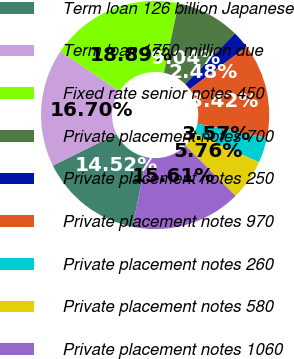<chart> <loc_0><loc_0><loc_500><loc_500><pie_chart><fcel>Term loan 126 billion Japanese<fcel>Term loan 1750 million due<fcel>Fixed rate senior notes 450<fcel>Private placement notes 700<fcel>Private placement notes 250<fcel>Private placement notes 970<fcel>Private placement notes 260<fcel>Private placement notes 580<fcel>Private placement notes 1060<nl><fcel>14.52%<fcel>16.7%<fcel>18.89%<fcel>9.04%<fcel>2.48%<fcel>13.42%<fcel>3.57%<fcel>5.76%<fcel>15.61%<nl></chart> 